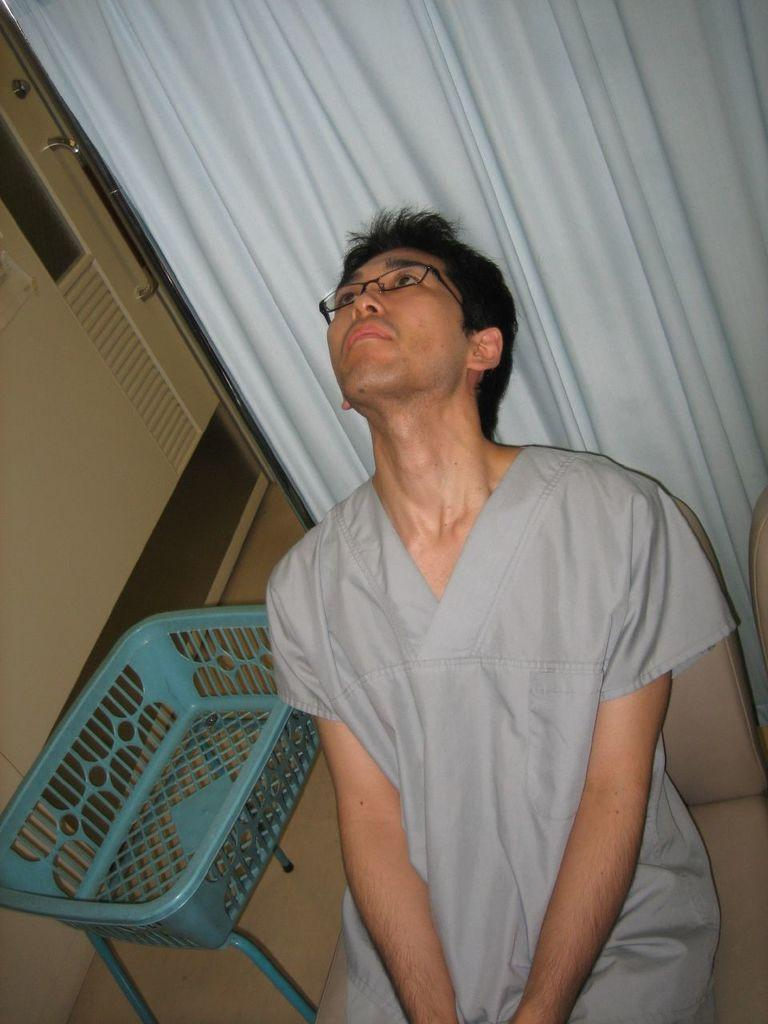What is the person in the image doing? The person is sitting on a chair in the image. Can you describe the person's appearance? The person is wearing specs. What is behind the person? There is a curtain behind the person. What object is near the person? There is a basket with stands near the person. Is there any entrance or exit visible in the image? Yes, there is a door in the image. Can you tell me how many toads are sitting on the wall in the image? There are no toads present in the image, and there is no wall visible. What historical event is being commemorated in the image? There is no indication of any historical event being commemorated in the image. 